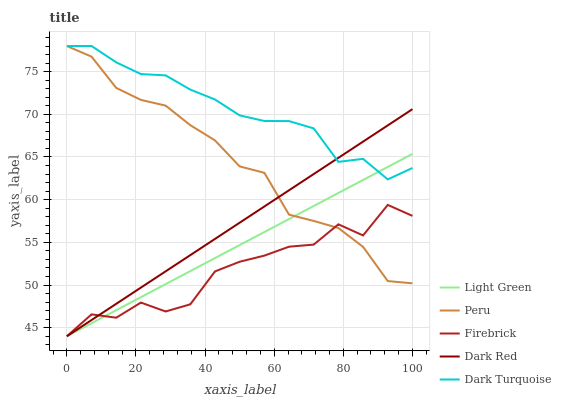Does Firebrick have the minimum area under the curve?
Answer yes or no. Yes. Does Dark Turquoise have the maximum area under the curve?
Answer yes or no. Yes. Does Peru have the minimum area under the curve?
Answer yes or no. No. Does Peru have the maximum area under the curve?
Answer yes or no. No. Is Dark Red the smoothest?
Answer yes or no. Yes. Is Firebrick the roughest?
Answer yes or no. Yes. Is Peru the smoothest?
Answer yes or no. No. Is Peru the roughest?
Answer yes or no. No. Does Dark Red have the lowest value?
Answer yes or no. Yes. Does Peru have the lowest value?
Answer yes or no. No. Does Dark Turquoise have the highest value?
Answer yes or no. Yes. Does Firebrick have the highest value?
Answer yes or no. No. Is Firebrick less than Dark Turquoise?
Answer yes or no. Yes. Is Dark Turquoise greater than Firebrick?
Answer yes or no. Yes. Does Peru intersect Light Green?
Answer yes or no. Yes. Is Peru less than Light Green?
Answer yes or no. No. Is Peru greater than Light Green?
Answer yes or no. No. Does Firebrick intersect Dark Turquoise?
Answer yes or no. No. 